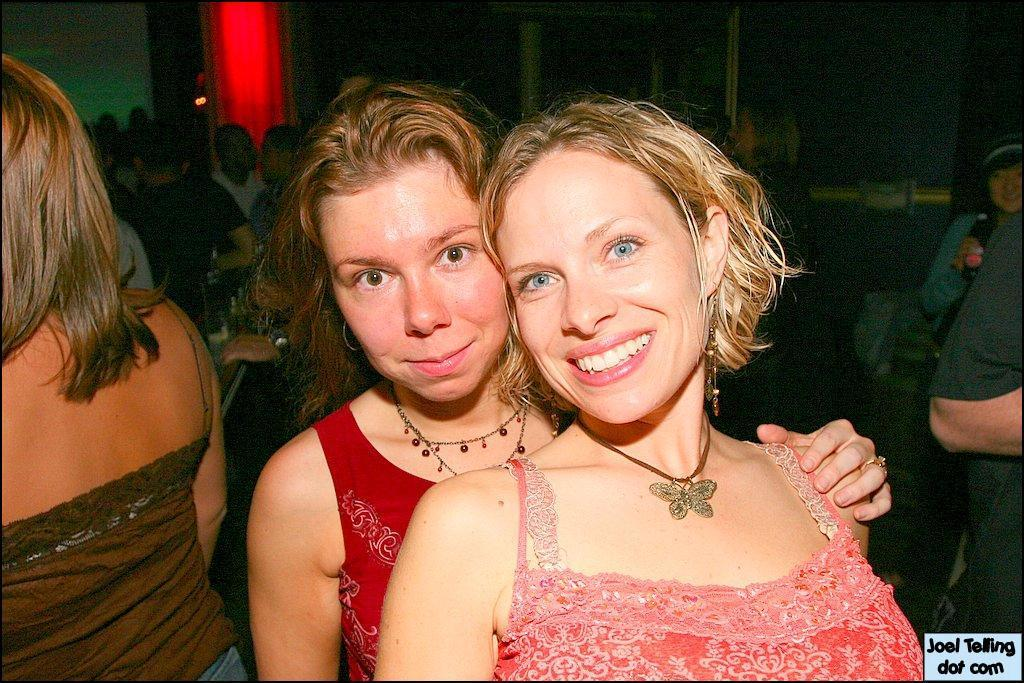What is the main subject of the image? The main subject of the image is a group of people. Can you describe the two women in the middle of the image? The two women in the middle of the image are smiling. What can be seen in the background of the image? There is a light visible in the background of the image. What type of tub is visible in the image? There is no tub present in the image. Are the women in the image on vacation? The image does not provide any information about the women being on vacation. 